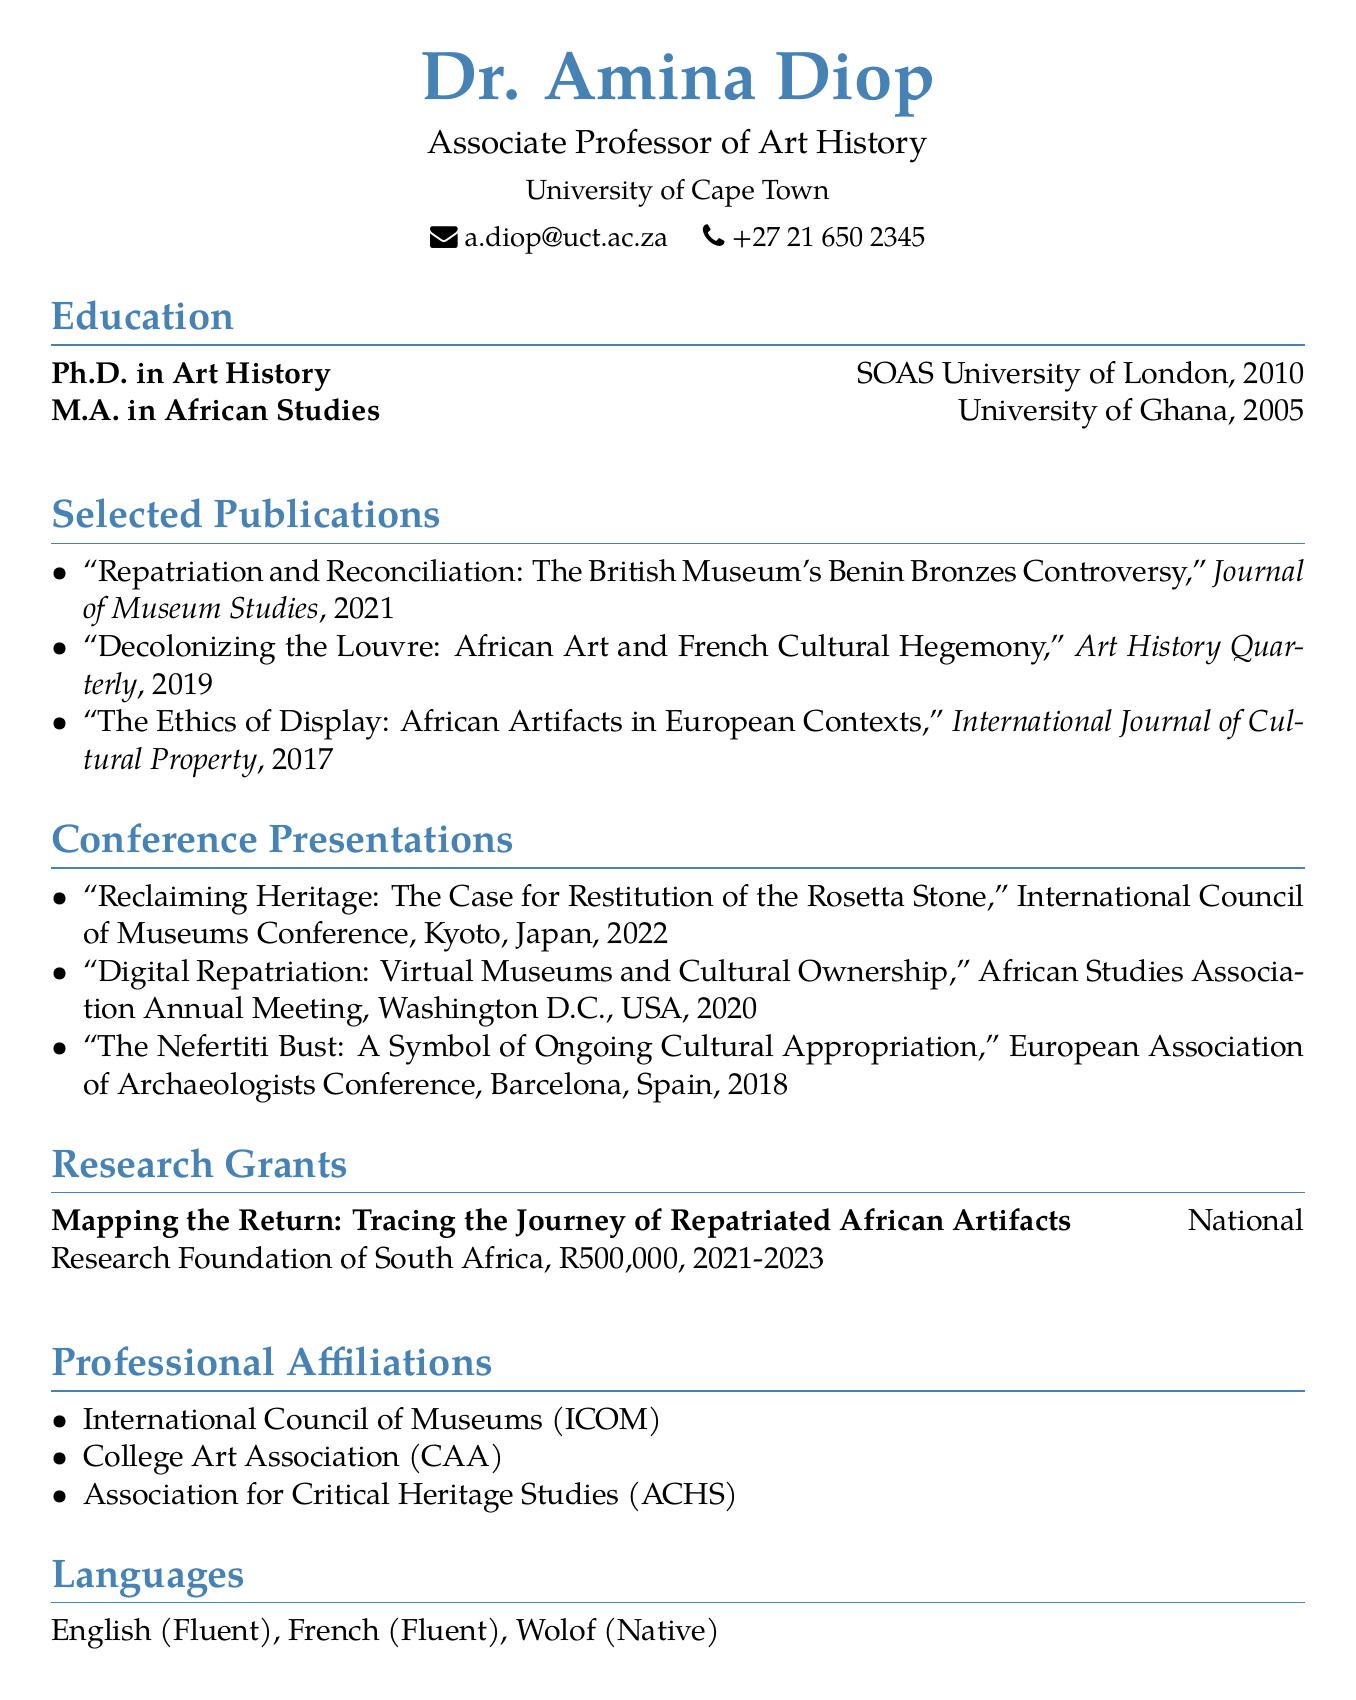what is the name of the Associate Professor? The document specifies the name of the Associate Professor as Dr. Amina Diop.
Answer: Dr. Amina Diop which university is Dr. Amina Diop affiliated with? The document states that Dr. Amina Diop is affiliated with the University of Cape Town.
Answer: University of Cape Town what year did Dr. Amina Diop complete her Ph.D.? According to the document, Dr. Amina Diop completed her Ph.D. in 2010.
Answer: 2010 how many publications are listed in the document? The document lists three publications under the Selected Publications section.
Answer: 3 which conference did Dr. Amina Diop present in Kyoto? The document indicates that she presented at the International Council of Museums Conference in Kyoto, Japan.
Answer: International Council of Museums Conference what is the title of the research grant mentioned? The document specifies that the title of the research grant is "Mapping the Return: Tracing the Journey of Repatriated African Artifacts."
Answer: Mapping the Return: Tracing the Journey of Repatriated African Artifacts which language is listed as native for Dr. Amina Diop? The document states that Dr. Amina Diop's native language is Wolof.
Answer: Wolof in what year was the publication on the British Museum's Benin Bronzes released? According to the document, the publication on the British Museum's Benin Bronzes was released in 2021.
Answer: 2021 